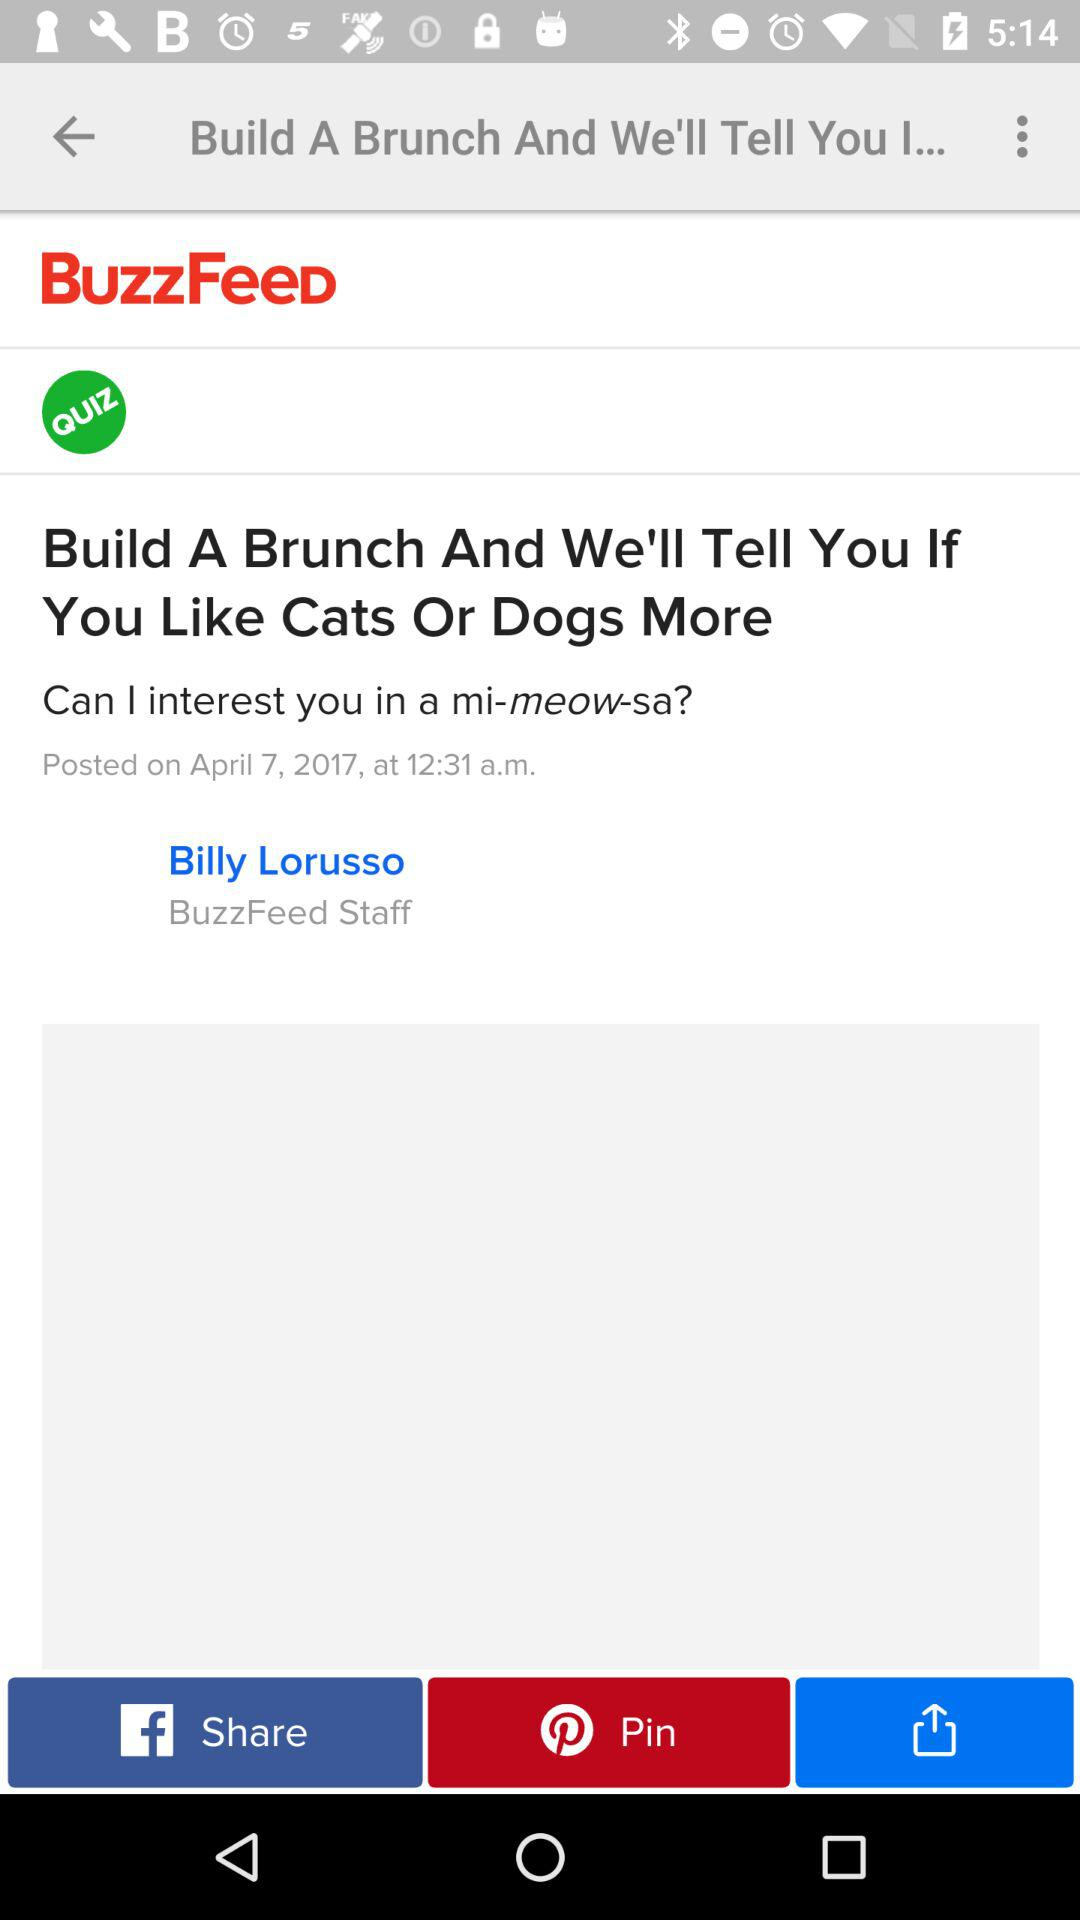What is the posted date of the article? The posted date is April 7, 2017. 